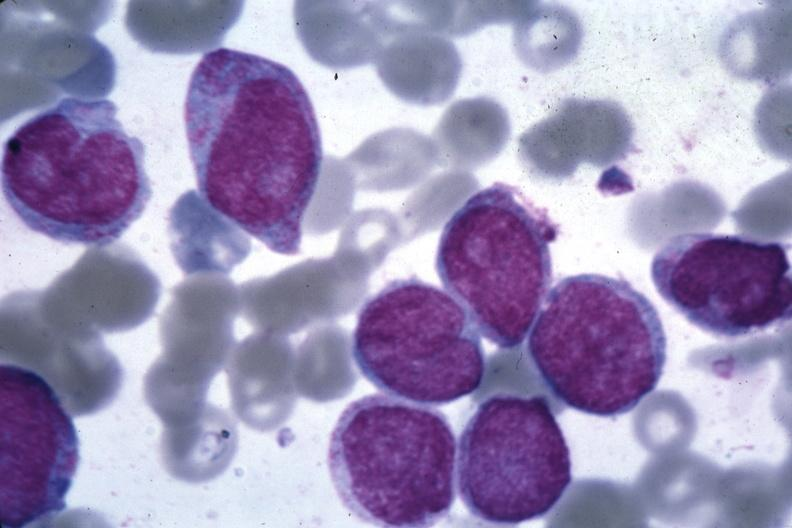what is present?
Answer the question using a single word or phrase. Acute myelogenous leukemia 